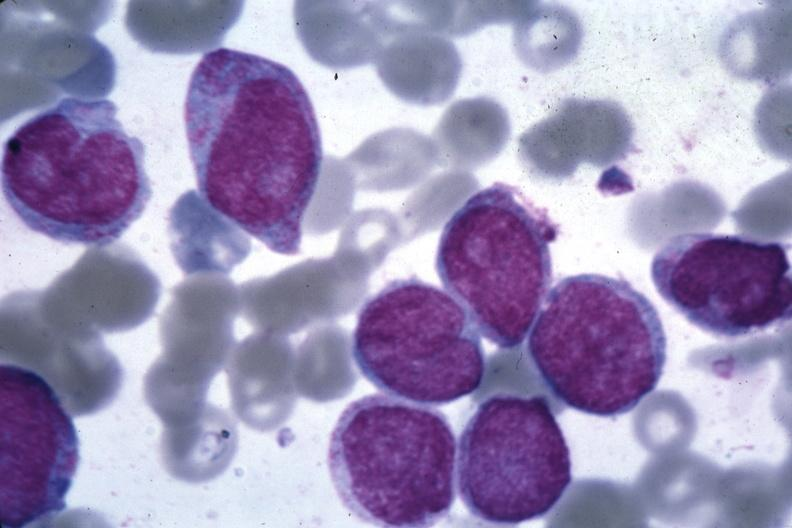what is present?
Answer the question using a single word or phrase. Acute myelogenous leukemia 